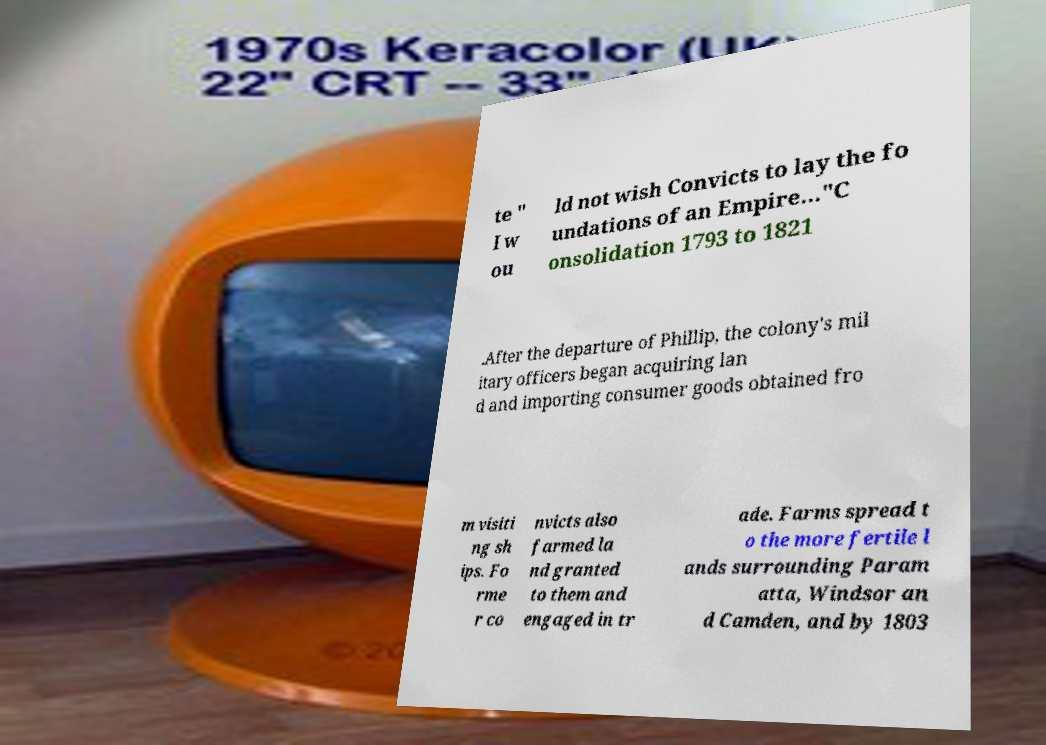Could you assist in decoding the text presented in this image and type it out clearly? te " I w ou ld not wish Convicts to lay the fo undations of an Empire..."C onsolidation 1793 to 1821 .After the departure of Phillip, the colony's mil itary officers began acquiring lan d and importing consumer goods obtained fro m visiti ng sh ips. Fo rme r co nvicts also farmed la nd granted to them and engaged in tr ade. Farms spread t o the more fertile l ands surrounding Param atta, Windsor an d Camden, and by 1803 